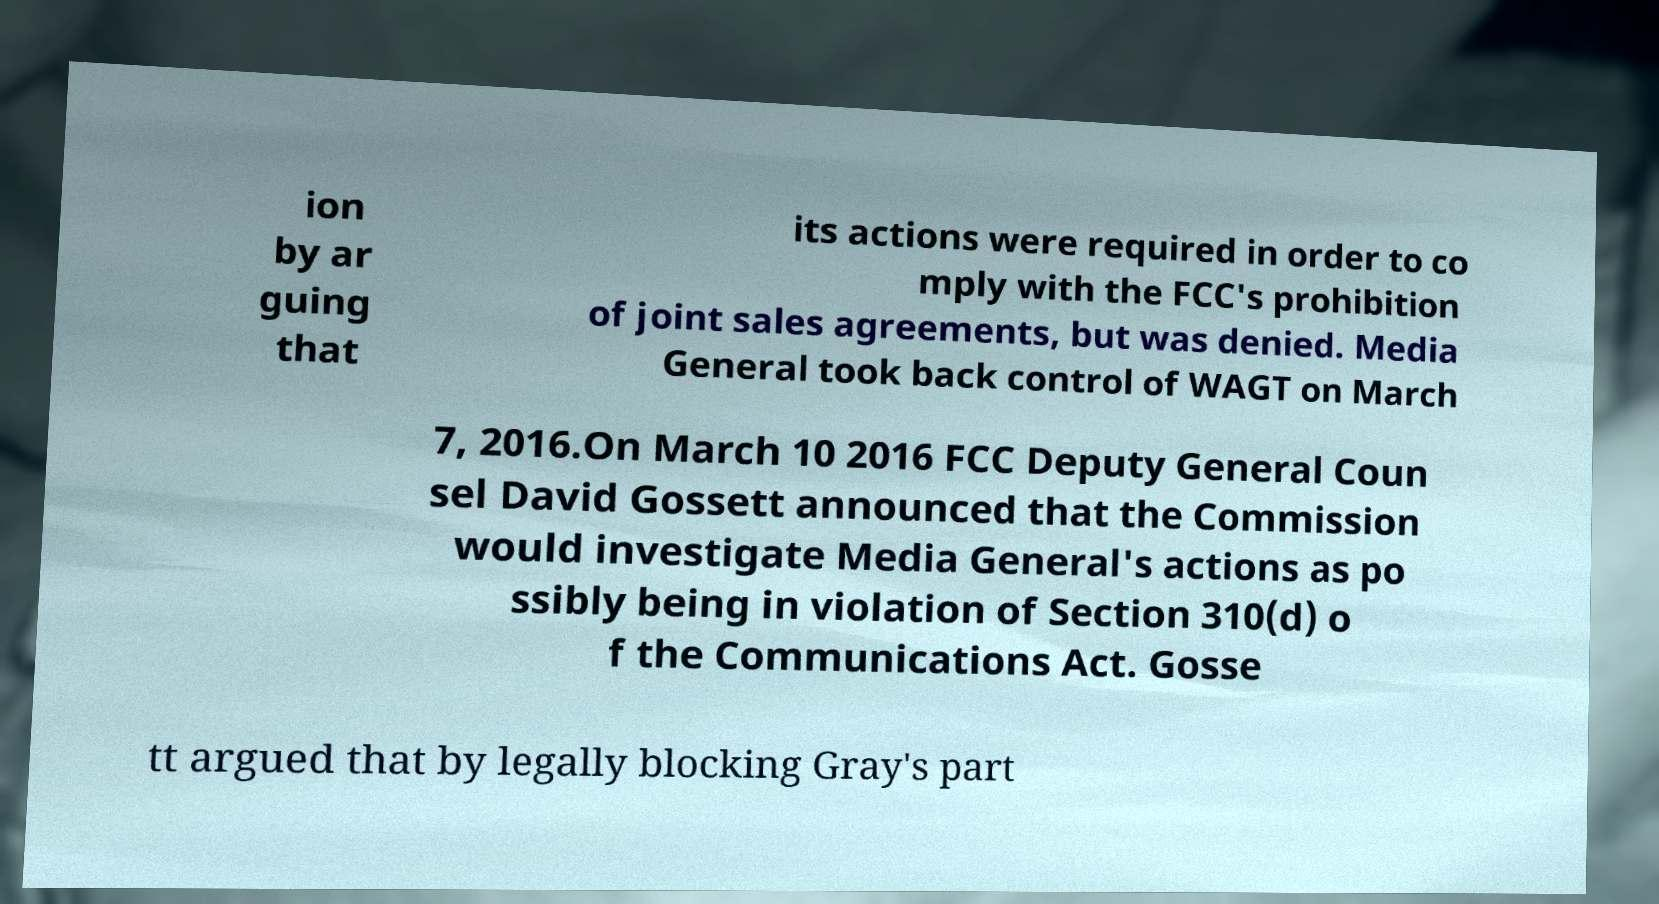Please identify and transcribe the text found in this image. ion by ar guing that its actions were required in order to co mply with the FCC's prohibition of joint sales agreements, but was denied. Media General took back control of WAGT on March 7, 2016.On March 10 2016 FCC Deputy General Coun sel David Gossett announced that the Commission would investigate Media General's actions as po ssibly being in violation of Section 310(d) o f the Communications Act. Gosse tt argued that by legally blocking Gray's part 